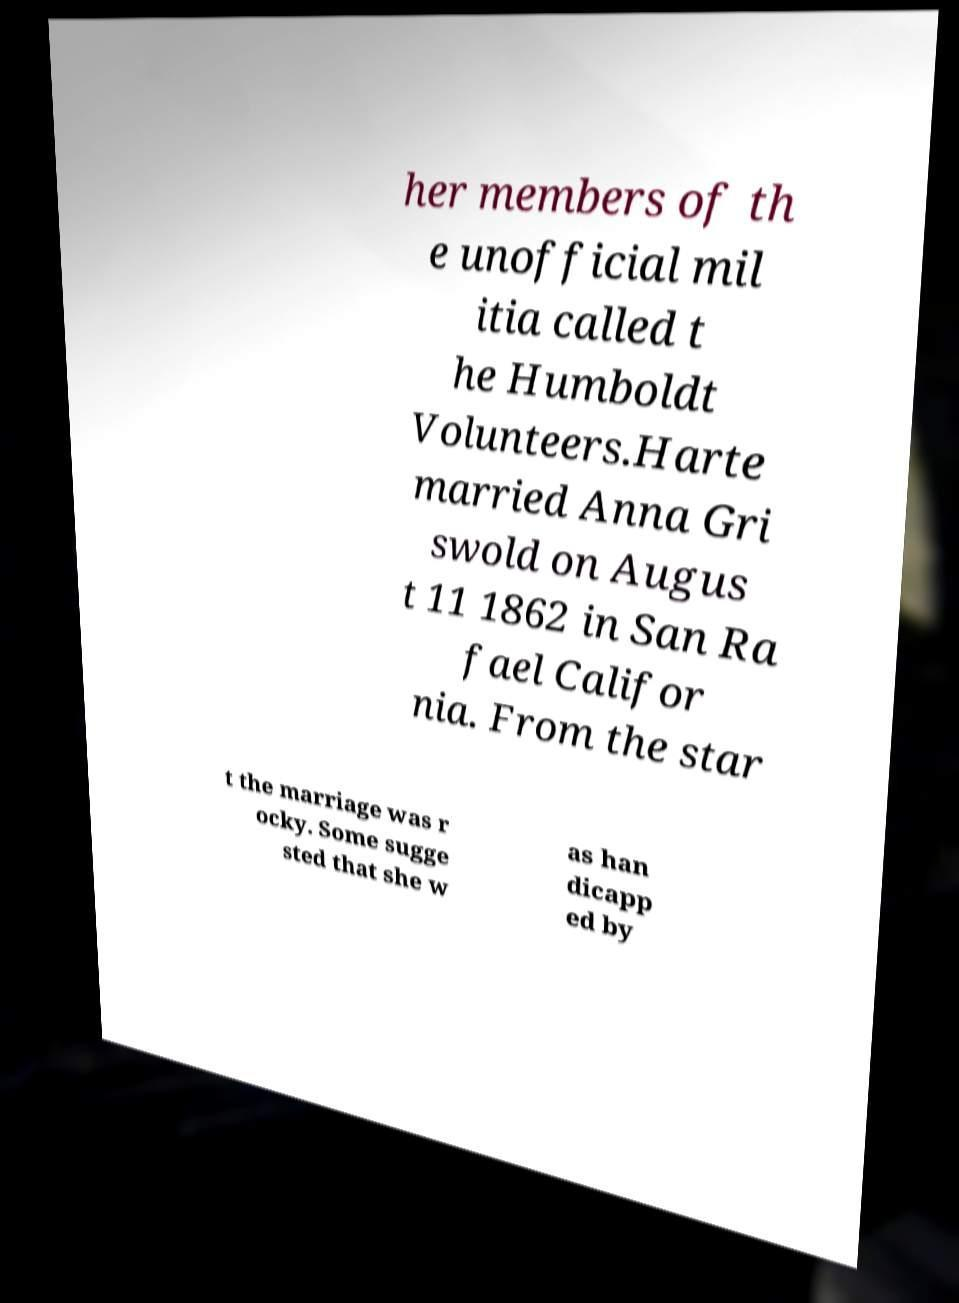For documentation purposes, I need the text within this image transcribed. Could you provide that? her members of th e unofficial mil itia called t he Humboldt Volunteers.Harte married Anna Gri swold on Augus t 11 1862 in San Ra fael Califor nia. From the star t the marriage was r ocky. Some sugge sted that she w as han dicapp ed by 